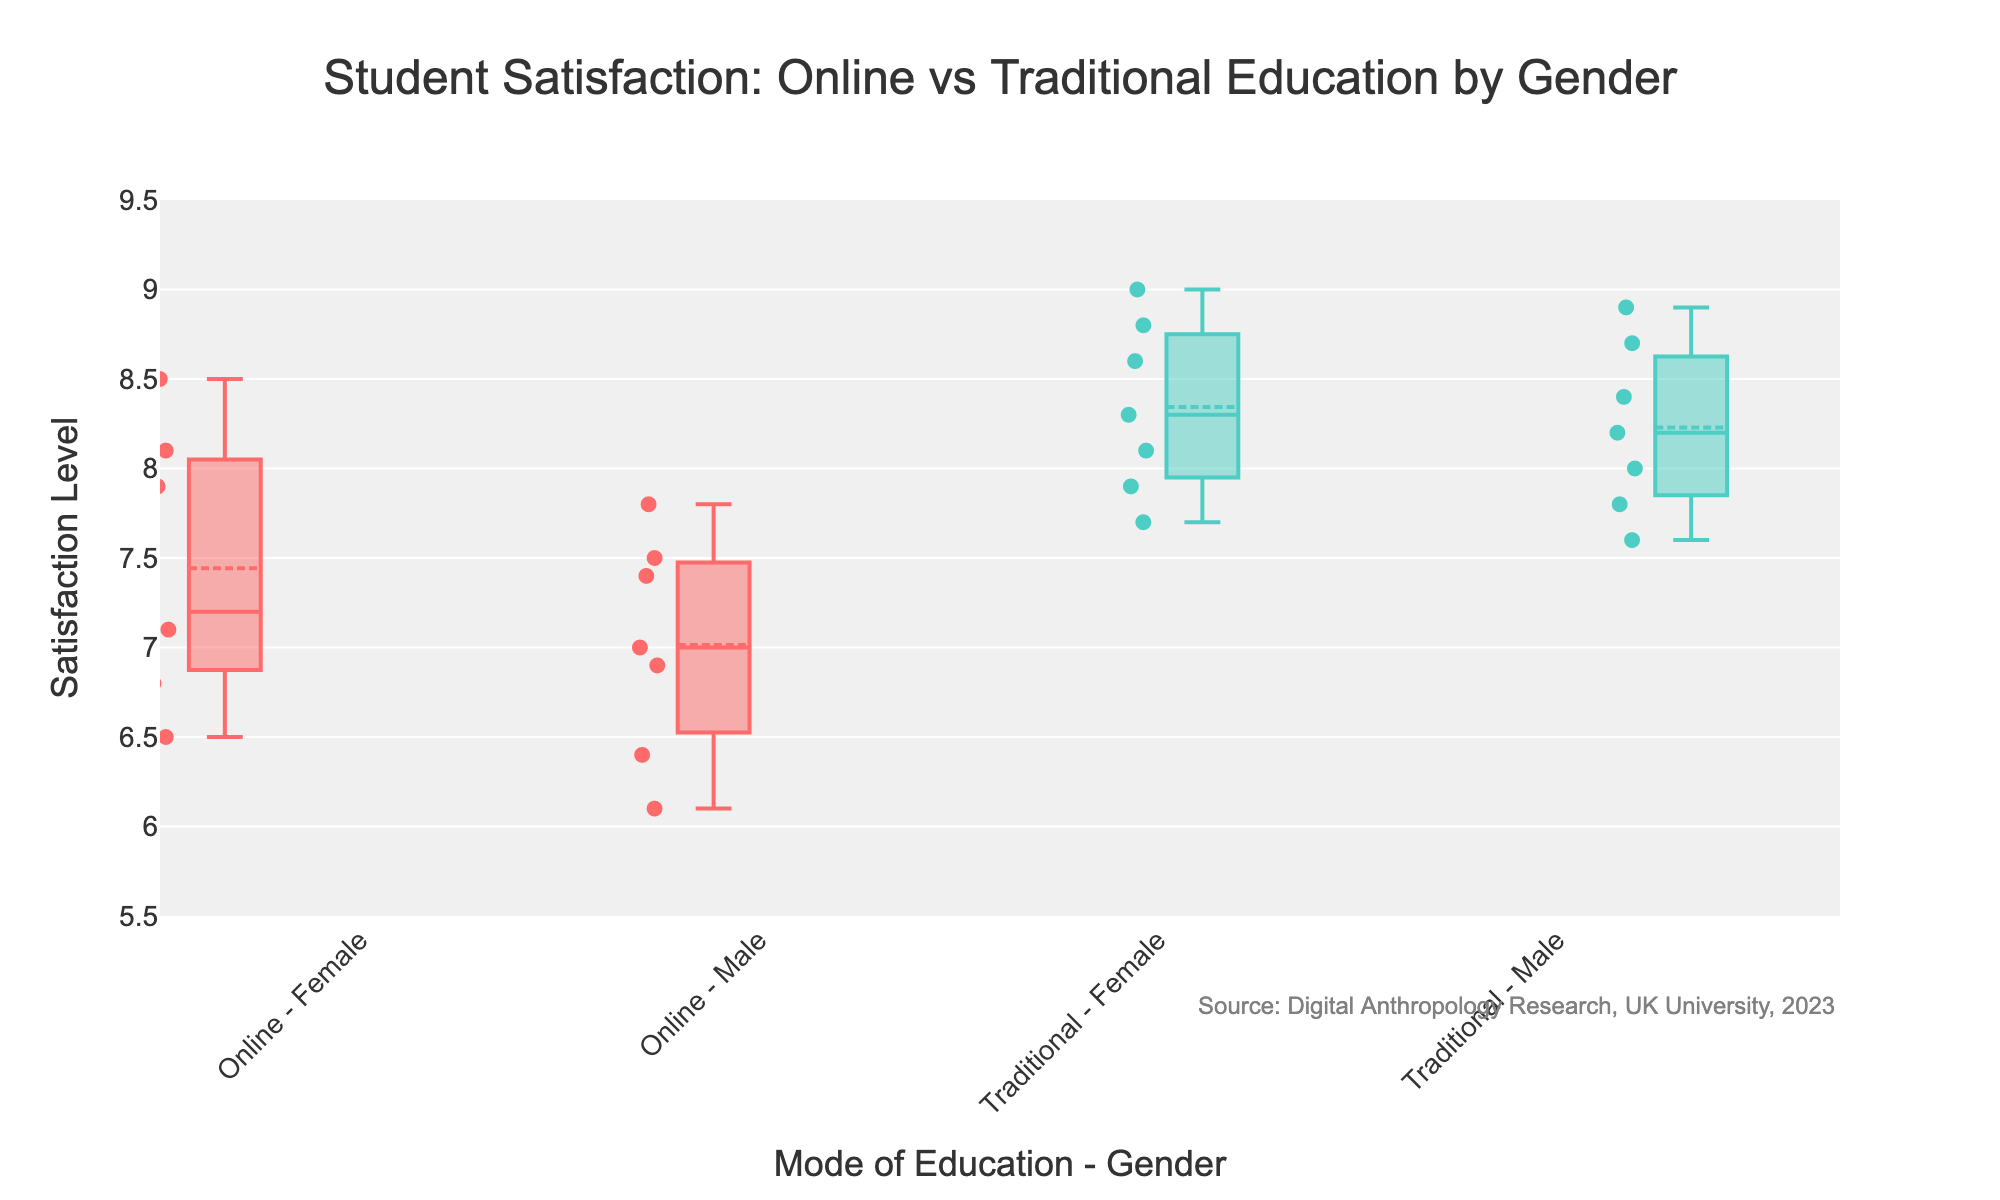How many data points are there in the "Online - Female" group? To determine the number of data points in the "Online - Female" group, count the individual points shown in the corresponding box on the plot.
Answer: 7 What is the median satisfaction level for males in online education? The median satisfaction level can be found by locating the center line inside the box for "Online - Male."
Answer: 7.0 Which group has a higher median satisfaction level, "Traditional - Female" or "Online - Male"? Compare the center lines of the boxes for "Traditional - Female" and "Online - Male." The higher median will be indicated by a higher line within the box.
Answer: Traditional - Female Between females and males, which gender has greater variability in satisfaction levels in traditional education? Variability can be assessed by comparing the interquartile ranges (the lengths of the boxes) for "Traditional - Female" and "Traditional - Male."
Answer: Male Does the "Online - Male" group have any outliers? Outliers are represented by individual points lying outside the whiskers of the box plot. Check if there are any isolated points beyond the whiskers for the "Online - Male" group.
Answer: No What's the average satisfaction level for females in traditional education? Sum the satisfaction levels for "Traditional - Female" and divide by the number of data points (8.3 + 7.9 + 9.0 + 8.8 + 7.7 + 8.1 + 8.6) / 7.
Answer: 8.2 Which group shows the highest maximum satisfaction level? The highest maximum satisfaction level is indicated by the top end of the whisker across all groups. Identify which group has the longest whisker extending upwards.
Answer: Traditional - Male Compare the lower quartile (Q1) values for "Online - Female" and "Online - Male." Which group has a higher Q1? The lower quartile (Q1) is indicated by the bottom line of the box. Compare these lines for "Online - Female" and "Online - Male."
Answer: Online - Female How many satisfaction levels are above 8.0 for the "Traditional - Female" group? Count the points above the value of 8.0 along the y-axis within the "Traditional - Female" box plot.
Answer: 5 